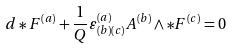Convert formula to latex. <formula><loc_0><loc_0><loc_500><loc_500>d \ast F ^ { \left ( a \right ) } + \frac { 1 } { Q } \varepsilon _ { \left ( b \right ) \left ( c \right ) } ^ { \left ( a \right ) } A ^ { \left ( b \right ) } \wedge \ast F ^ { \left ( c \right ) } = 0</formula> 